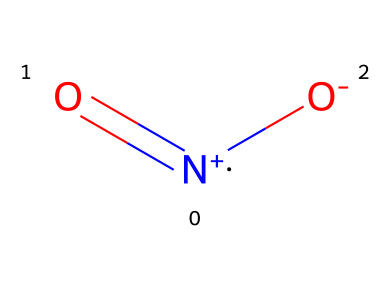What is the name of this chemical? The SMILES representation provided corresponds to the structure of nitrogen dioxide, which is a well-known nitrogen oxide commonly found in bus exhaust emissions.
Answer: nitrogen dioxide How many oxygen atoms are present in the molecule? By analyzing the SMILES representation, there are two oxygen atoms indicated by two "O" symbols in the structure.
Answer: 2 What type of molecule is this? This SMILES structure represents a gas, specifically a nitrogen oxide, which is a type of atmospheric pollutant typically released from combustion engines.
Answer: gas Does this molecule have a formal charge? The structure shows a nitrogen atom with a positive charge and one of the oxygen atoms has a negative charge, indicating that the molecule contains formal charges.
Answer: yes How many total atoms are in the molecule? Adding the atoms present in the SMILES representation: 1 nitrogen and 2 oxygen gives a total of 3 atoms.
Answer: 3 Is this gas likely to contribute to air pollution? As a common nitrogen oxide released from vehicles, nitrogen dioxide is known to contribute to air pollution, particularly in urban areas with high traffic.
Answer: yes What is the oxidation state of nitrogen in this molecule? In nitrogen dioxide, nitrogen typically has an oxidation state of +4, as it forms two bonds with oxygen atoms and carries a formal charge.
Answer: +4 